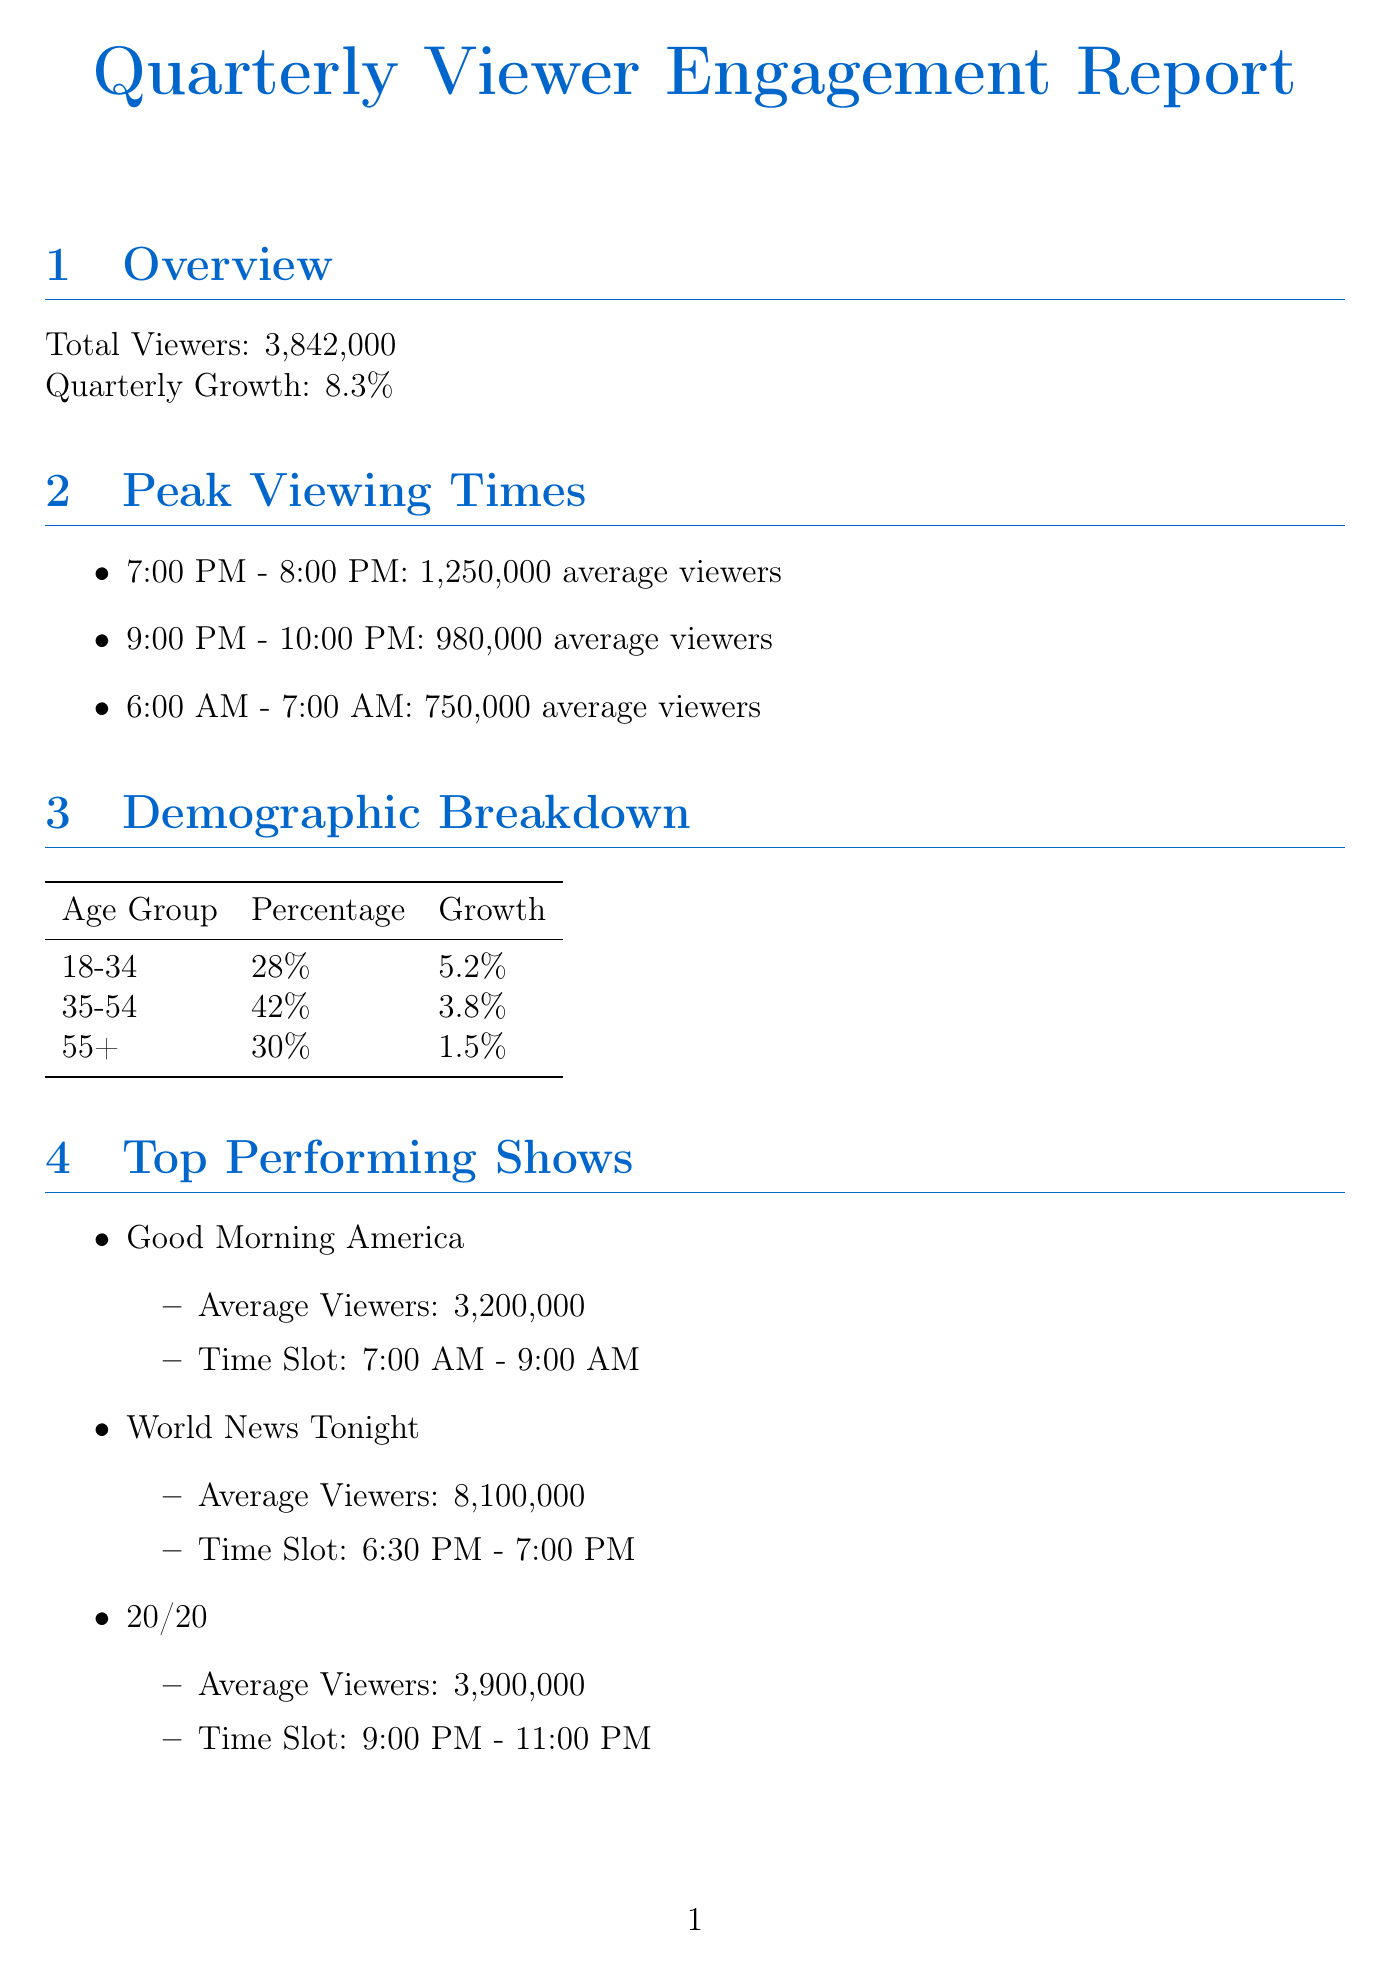What is the total number of viewers? The total number of viewers is given in the overview section of the document, which states "Total Viewers: 3,842,000".
Answer: 3,842,000 What is the quarterly growth percentage? The percentage of quarterly growth is provided in the overview section, which mentions "Quarterly Growth: 8.3%".
Answer: 8.3% What age group has the highest percentage of viewers? The demographic breakdown lists percentages for various age groups, where "35-54" has the highest percentage at "42%".
Answer: 35-54 What is the average number of viewers during the peak viewing time from 7:00 PM to 8:00 PM? The peak viewing times section specifies "7:00 PM - 8:00 PM: 1,250,000 average viewers".
Answer: 1,250,000 Which social media platform has the most total followers? The total followers section shows that "Facebook" has the highest total with "22,500,000" followers.
Answer: Facebook What is the journalist satisfaction score? The newsroom mood indicators section provides the score, which states "Journalist Satisfaction Score: 8.2".
Answer: 8.2 What initiatives promote team bonding in the newsroom? The newsroom initiatives section mentions "Weekly Mood Boosters" that are designed for fun activities to promote team bonding.
Answer: Weekly Mood Boosters Which show has the highest average viewers? The top performing shows section lists "World News Tonight" with "8,100,000" average viewers, making it the highest.
Answer: World News Tonight What potential growth percentage is mentioned for Gen Z viewership? The future trends section states that Gen Z (18-24) has a "Potential Growth: 15%".
Answer: 15% 